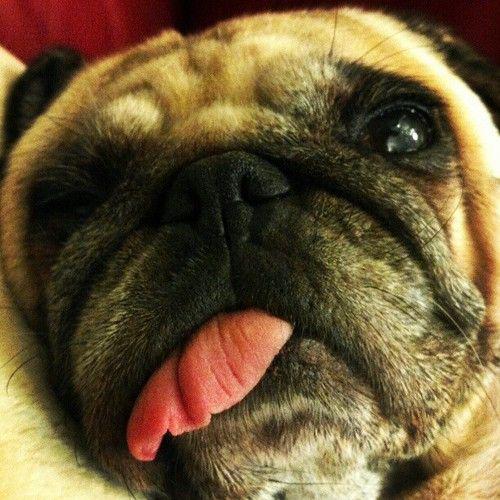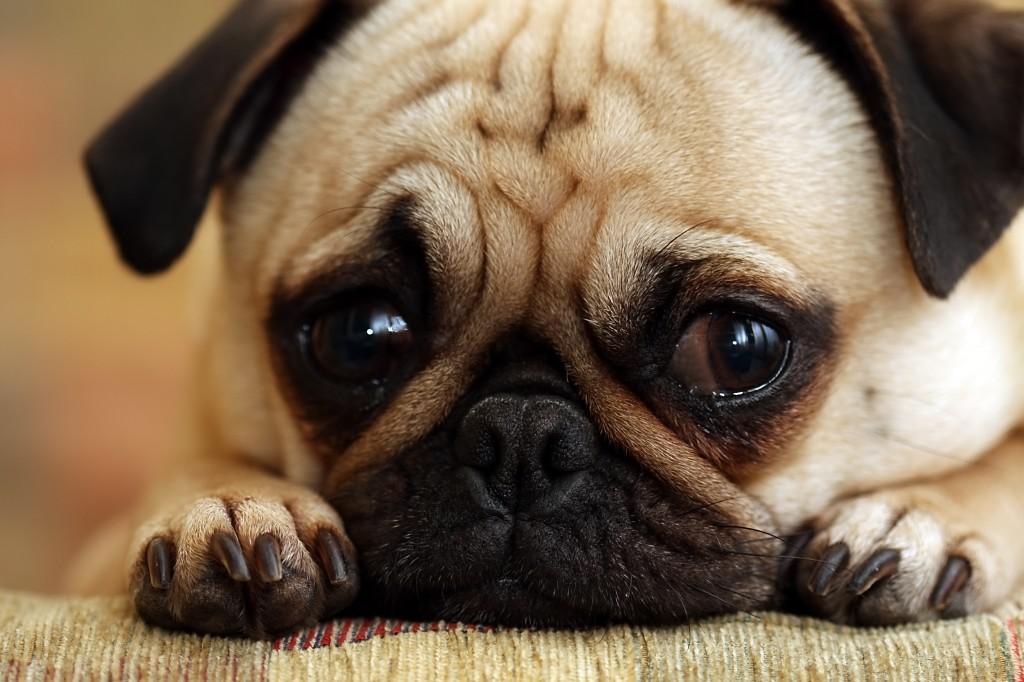The first image is the image on the left, the second image is the image on the right. Assess this claim about the two images: "a single pug is sleeping with it's tongue sticking out". Correct or not? Answer yes or no. No. The first image is the image on the left, the second image is the image on the right. Given the left and right images, does the statement "One image shows pugs sleeping side-by-side on something plush, and the other image shows one sleeping pug with its tongue hanging out." hold true? Answer yes or no. No. 